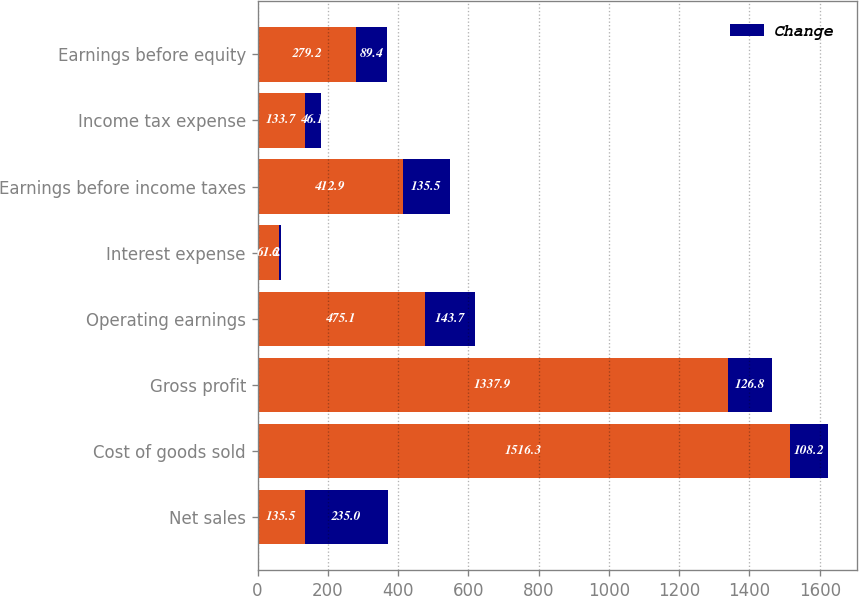Convert chart to OTSL. <chart><loc_0><loc_0><loc_500><loc_500><stacked_bar_chart><ecel><fcel>Net sales<fcel>Cost of goods sold<fcel>Gross profit<fcel>Operating earnings<fcel>Interest expense<fcel>Earnings before income taxes<fcel>Income tax expense<fcel>Earnings before equity<nl><fcel>nan<fcel>135.5<fcel>1516.3<fcel>1337.9<fcel>475.1<fcel>61.2<fcel>412.9<fcel>133.7<fcel>279.2<nl><fcel>Change<fcel>235<fcel>108.2<fcel>126.8<fcel>143.7<fcel>6.4<fcel>135.5<fcel>46.1<fcel>89.4<nl></chart> 